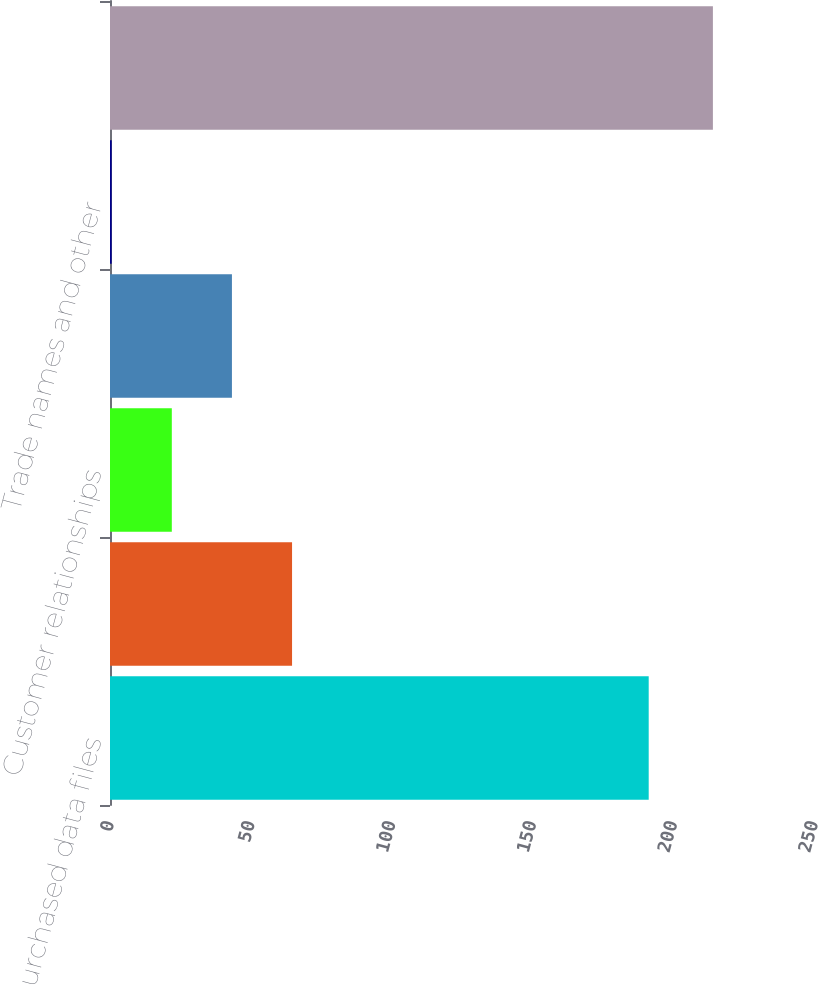<chart> <loc_0><loc_0><loc_500><loc_500><bar_chart><fcel>Purchased data files<fcel>Acquired software and<fcel>Customer relationships<fcel>Non-compete agreements<fcel>Trade names and other<fcel>Total definite-lived<nl><fcel>191.3<fcel>64.65<fcel>21.95<fcel>43.3<fcel>0.6<fcel>214.1<nl></chart> 